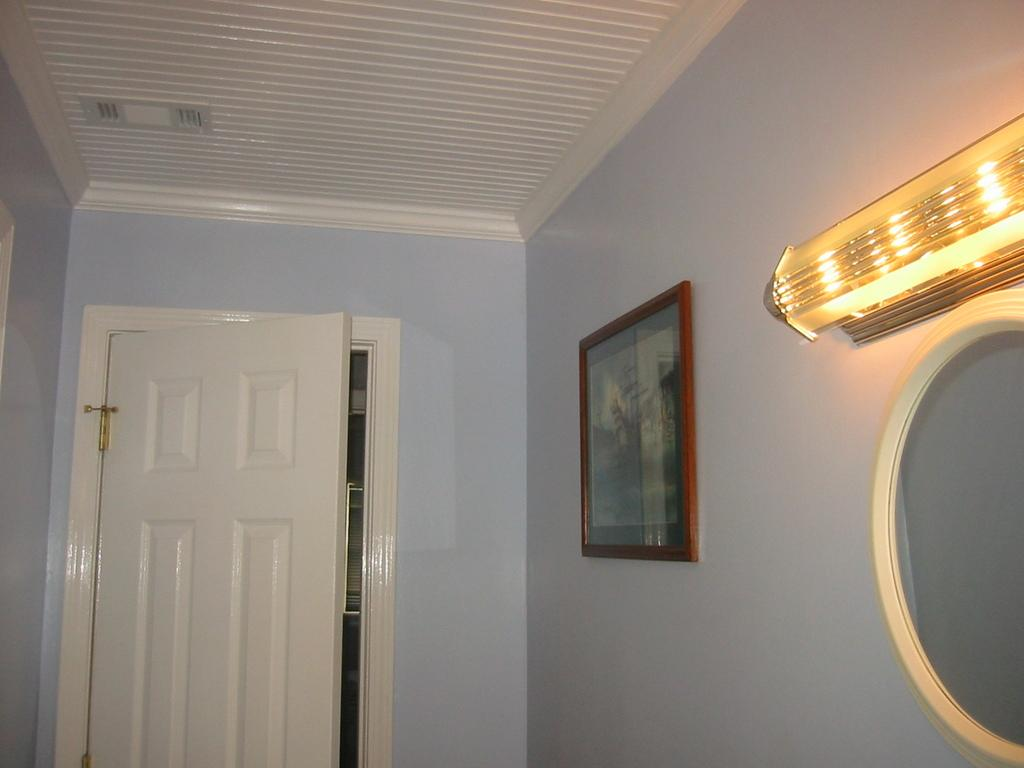What is attached to the wall in the image? There is a frame attached to the wall in the image. What is inside the frame? The image does not provide information about what is inside the frame. What can be seen in the mirror in the image? The image does not provide information about what can be seen in the mirror. What type of lighting is present in the image? There is a light on the wall in the image. What color is the wall in the image? The wall is in purple color. What type of door is present in the image? There is a white door in the image. What type of canvas is being used for the argument in the image? There is no argument or canvas present in the image. How much rice is visible on the floor in the image? There is no rice present in the image. 